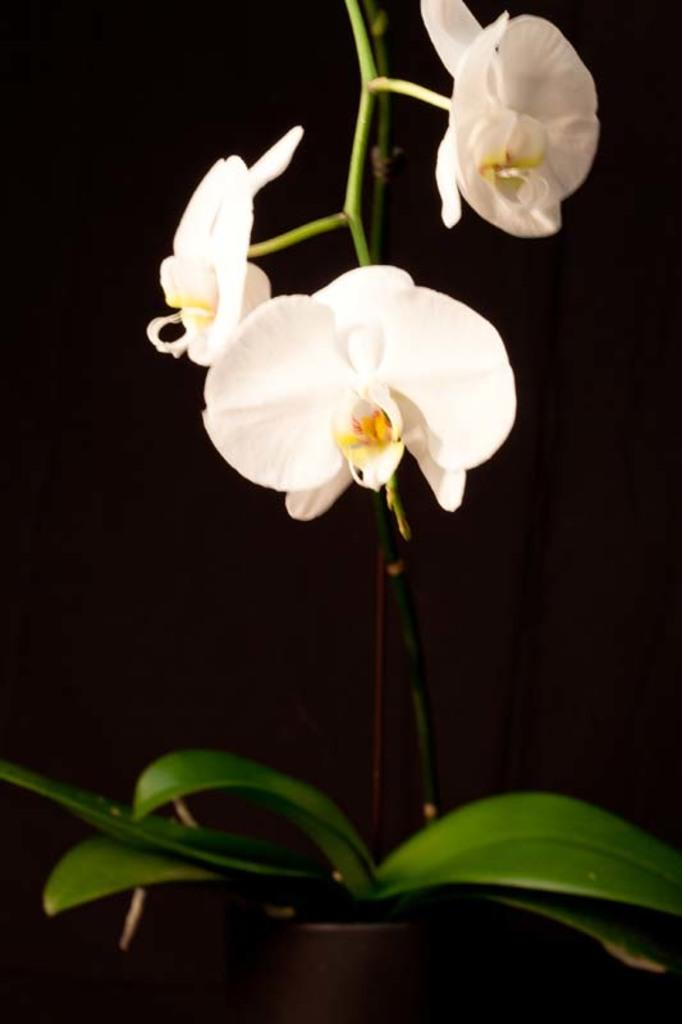What is present in the picture? There is a plant in the picture. What can be observed about the flowers on the plant? The plant has white flowers. How would you describe the background of the image? The background of the image is dark. How many sheep are visible in the image? There are no sheep present in the image; it features a plant with white flowers against a dark background. 